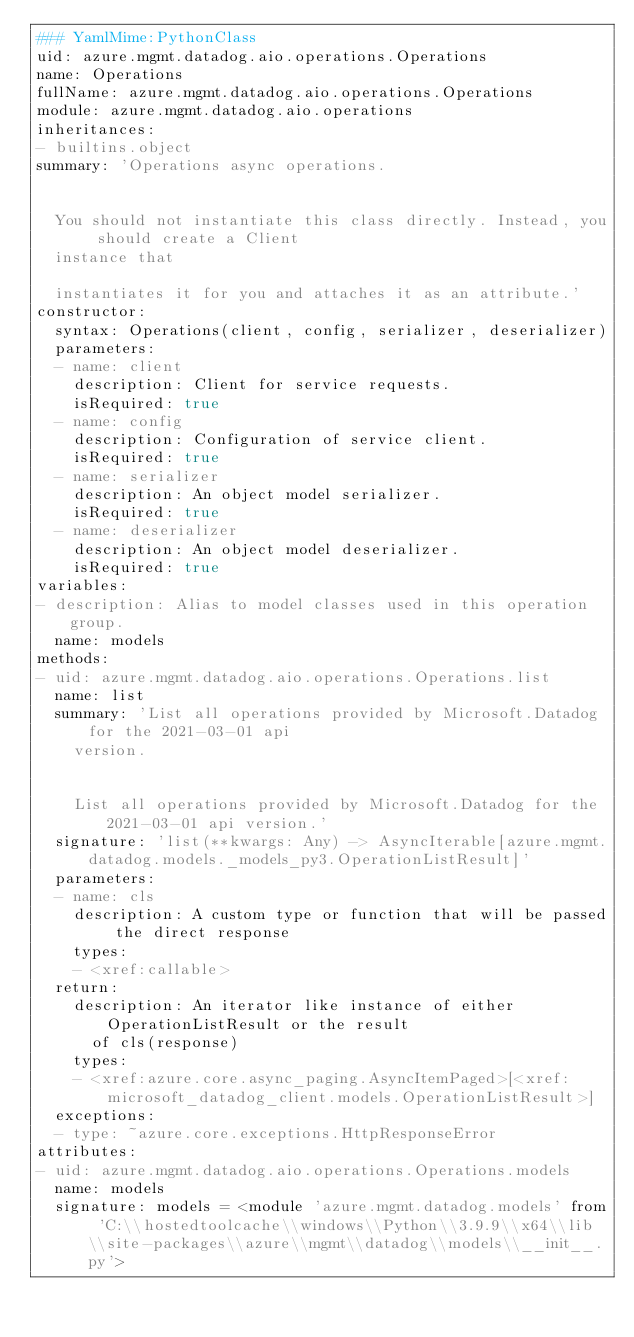Convert code to text. <code><loc_0><loc_0><loc_500><loc_500><_YAML_>### YamlMime:PythonClass
uid: azure.mgmt.datadog.aio.operations.Operations
name: Operations
fullName: azure.mgmt.datadog.aio.operations.Operations
module: azure.mgmt.datadog.aio.operations
inheritances:
- builtins.object
summary: 'Operations async operations.


  You should not instantiate this class directly. Instead, you should create a Client
  instance that

  instantiates it for you and attaches it as an attribute.'
constructor:
  syntax: Operations(client, config, serializer, deserializer)
  parameters:
  - name: client
    description: Client for service requests.
    isRequired: true
  - name: config
    description: Configuration of service client.
    isRequired: true
  - name: serializer
    description: An object model serializer.
    isRequired: true
  - name: deserializer
    description: An object model deserializer.
    isRequired: true
variables:
- description: Alias to model classes used in this operation group.
  name: models
methods:
- uid: azure.mgmt.datadog.aio.operations.Operations.list
  name: list
  summary: 'List all operations provided by Microsoft.Datadog for the 2021-03-01 api
    version.


    List all operations provided by Microsoft.Datadog for the 2021-03-01 api version.'
  signature: 'list(**kwargs: Any) -> AsyncIterable[azure.mgmt.datadog.models._models_py3.OperationListResult]'
  parameters:
  - name: cls
    description: A custom type or function that will be passed the direct response
    types:
    - <xref:callable>
  return:
    description: An iterator like instance of either OperationListResult or the result
      of cls(response)
    types:
    - <xref:azure.core.async_paging.AsyncItemPaged>[<xref:microsoft_datadog_client.models.OperationListResult>]
  exceptions:
  - type: ~azure.core.exceptions.HttpResponseError
attributes:
- uid: azure.mgmt.datadog.aio.operations.Operations.models
  name: models
  signature: models = <module 'azure.mgmt.datadog.models' from 'C:\\hostedtoolcache\\windows\\Python\\3.9.9\\x64\\lib\\site-packages\\azure\\mgmt\\datadog\\models\\__init__.py'>
</code> 